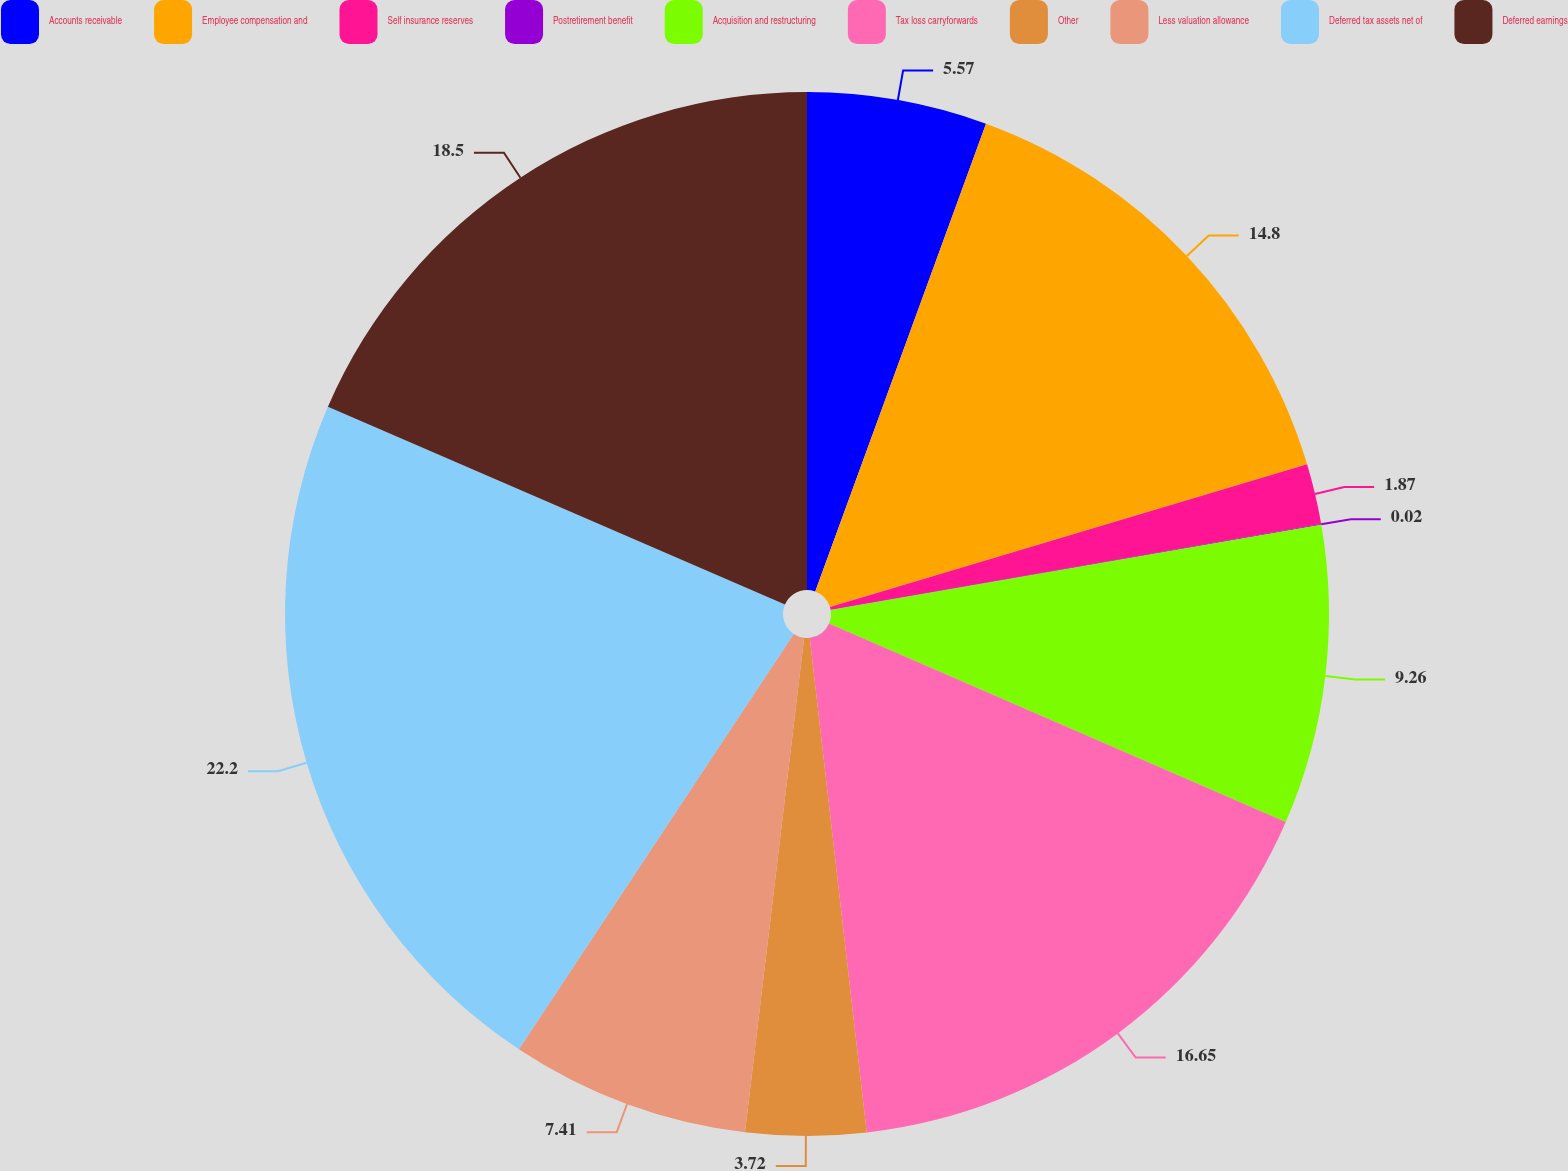<chart> <loc_0><loc_0><loc_500><loc_500><pie_chart><fcel>Accounts receivable<fcel>Employee compensation and<fcel>Self insurance reserves<fcel>Postretirement benefit<fcel>Acquisition and restructuring<fcel>Tax loss carryforwards<fcel>Other<fcel>Less valuation allowance<fcel>Deferred tax assets net of<fcel>Deferred earnings<nl><fcel>5.57%<fcel>14.8%<fcel>1.87%<fcel>0.02%<fcel>9.26%<fcel>16.65%<fcel>3.72%<fcel>7.41%<fcel>22.19%<fcel>18.5%<nl></chart> 